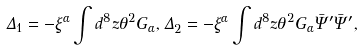Convert formula to latex. <formula><loc_0><loc_0><loc_500><loc_500>\Delta _ { 1 } = - \xi ^ { \alpha } \int d ^ { 8 } z \theta ^ { 2 } G _ { \alpha } , \Delta _ { 2 } = - \xi ^ { \alpha } \int d ^ { 8 } z \theta ^ { 2 } G _ { \alpha } \bar { \Psi } ^ { \prime } \bar { \Psi } ^ { \prime } ,</formula> 